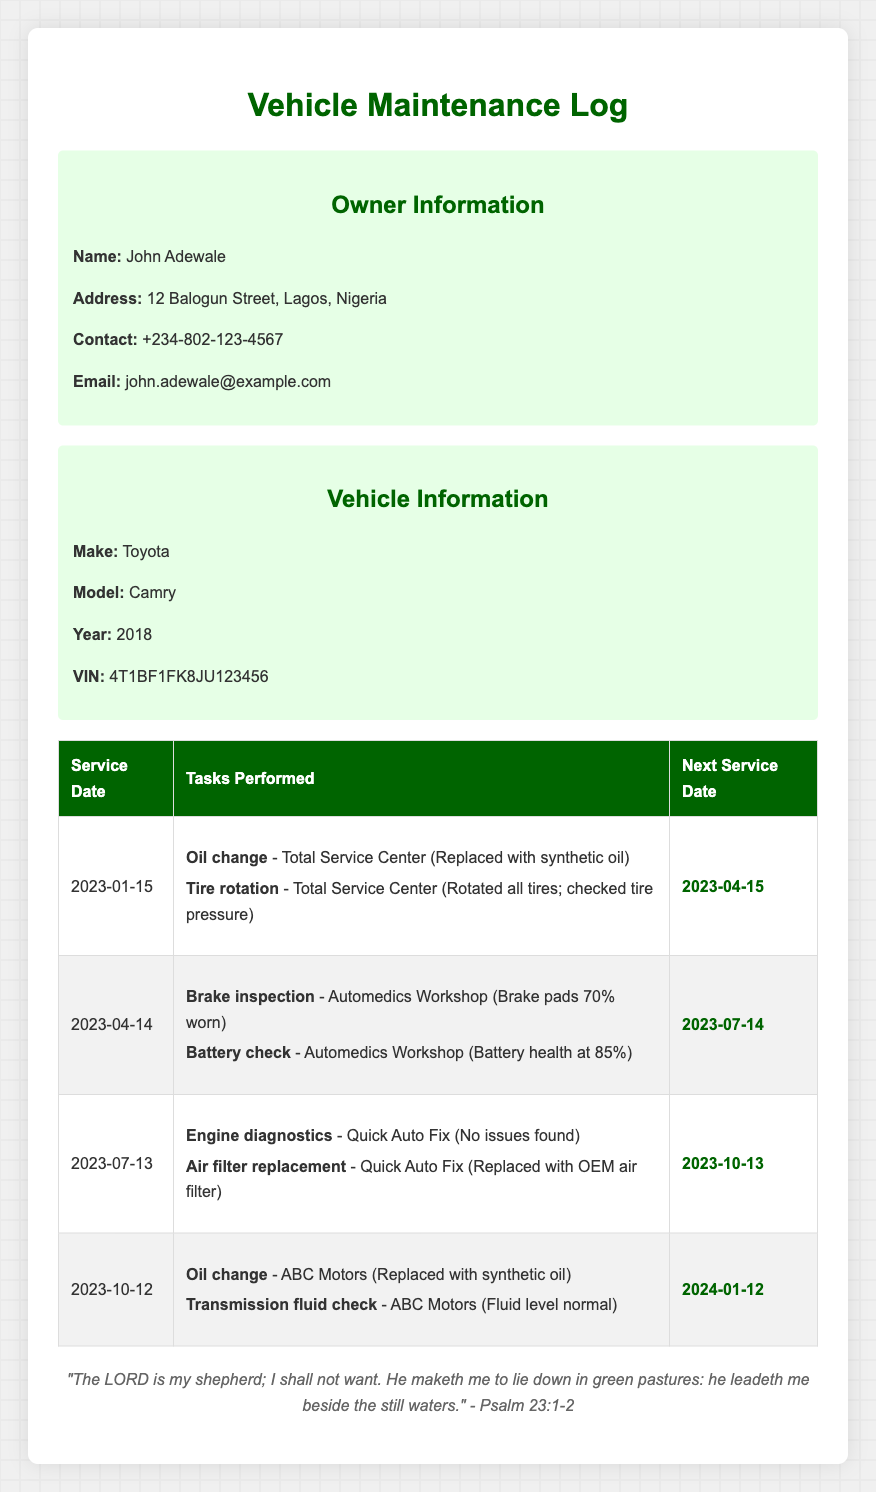What is the name of the vehicle owner? The name of the vehicle owner is provided in the owner information section of the document.
Answer: John Adewale What is the next service date after October 12, 2023? The next service date listed after October 12, 2023 is provided in the maintenance table.
Answer: January 12, 2024 How many tasks were performed during the service on April 14, 2023? The number of tasks is counted from the tasks performed during the service on that date in the maintenance log.
Answer: 2 What was replaced during the service on January 15, 2023? The replaced item for the service on this date can be found in the task list section of the log.
Answer: Synthetic oil What is the battery health percentage checked on April 14, 2023? The battery health percentage is specified in the tasks performed during that service date.
Answer: 85% Which workshop carried out the brake inspection? The workshop that performed the brake inspection is indicated next to the task in the log.
Answer: Automedics Workshop What was the issue found during the engine diagnostics on July 13, 2023? The document provides information on what was found during this maintenance check.
Answer: No issues found Which service center replaced the air filter? The service center that replaced the air filter is mentioned in the related task during that service date.
Answer: Quick Auto Fix What is the vehicle's make? The make of the vehicle is included in the vehicle information section of the document.
Answer: Toyota 